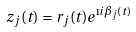Convert formula to latex. <formula><loc_0><loc_0><loc_500><loc_500>z _ { j } ( t ) = r _ { j } ( t ) e ^ { \i i \beta _ { j } ( t ) }</formula> 